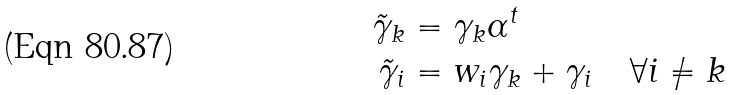<formula> <loc_0><loc_0><loc_500><loc_500>\tilde { \gamma } _ { k } & = \gamma _ { k } \alpha ^ { t } \\ \tilde { \gamma } _ { i } & = w _ { i } \gamma _ { k } + \gamma _ { i } \quad \forall i \neq k</formula> 